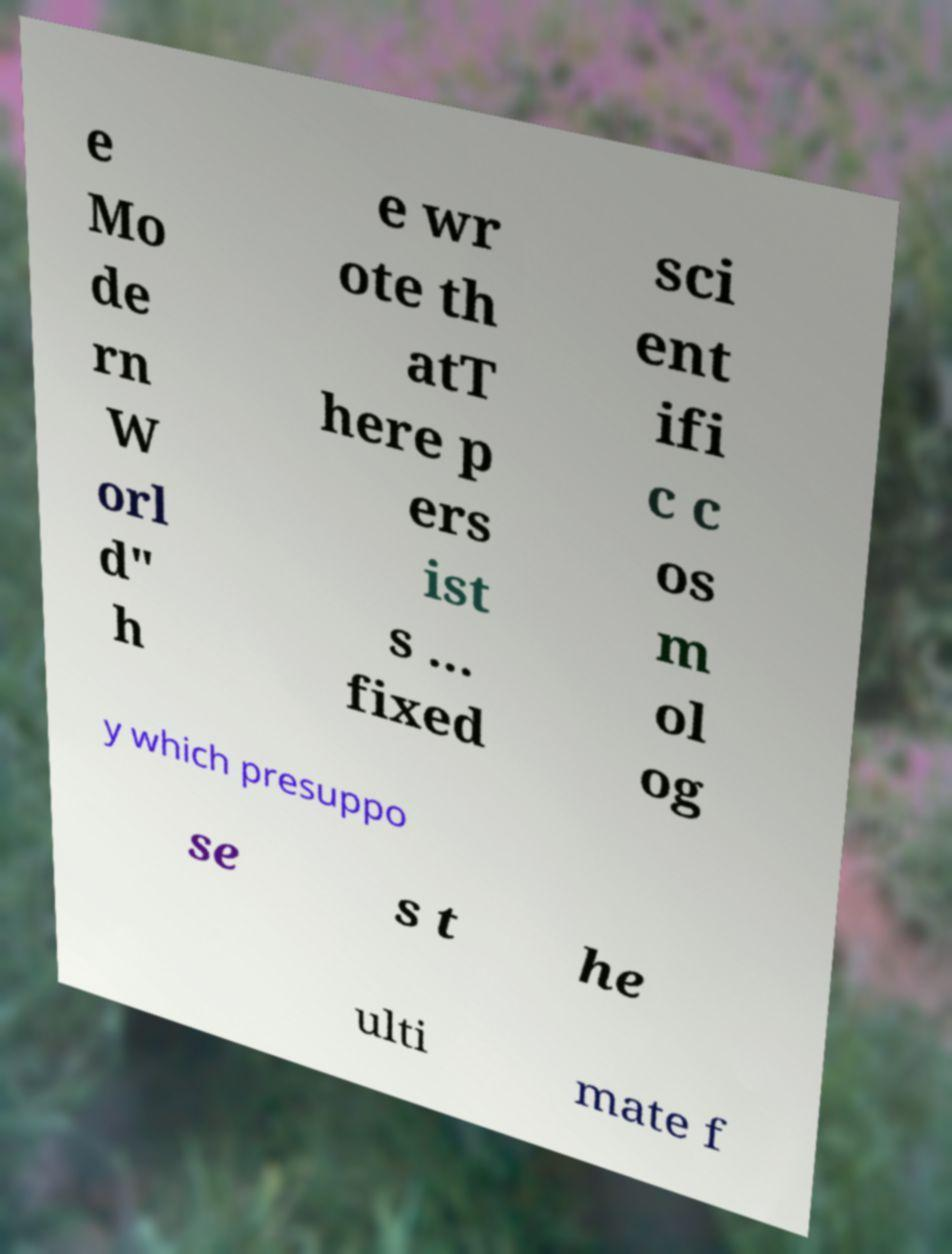Could you assist in decoding the text presented in this image and type it out clearly? e Mo de rn W orl d" h e wr ote th atT here p ers ist s ... fixed sci ent ifi c c os m ol og y which presuppo se s t he ulti mate f 